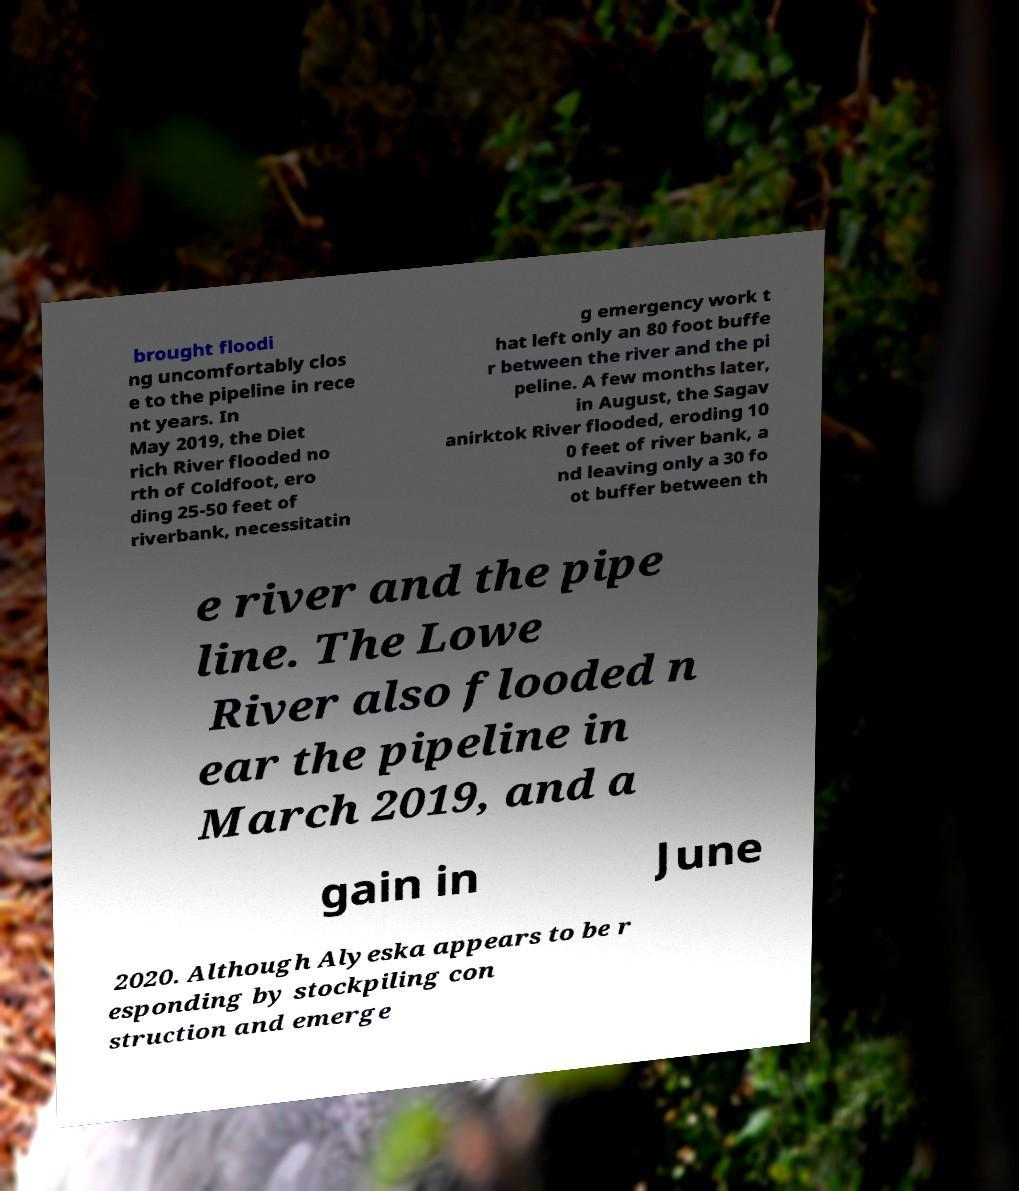Please read and relay the text visible in this image. What does it say? brought floodi ng uncomfortably clos e to the pipeline in rece nt years. In May 2019, the Diet rich River flooded no rth of Coldfoot, ero ding 25-50 feet of riverbank, necessitatin g emergency work t hat left only an 80 foot buffe r between the river and the pi peline. A few months later, in August, the Sagav anirktok River flooded, eroding 10 0 feet of river bank, a nd leaving only a 30 fo ot buffer between th e river and the pipe line. The Lowe River also flooded n ear the pipeline in March 2019, and a gain in June 2020. Although Alyeska appears to be r esponding by stockpiling con struction and emerge 